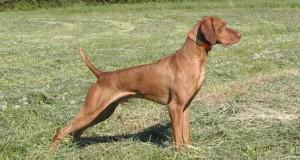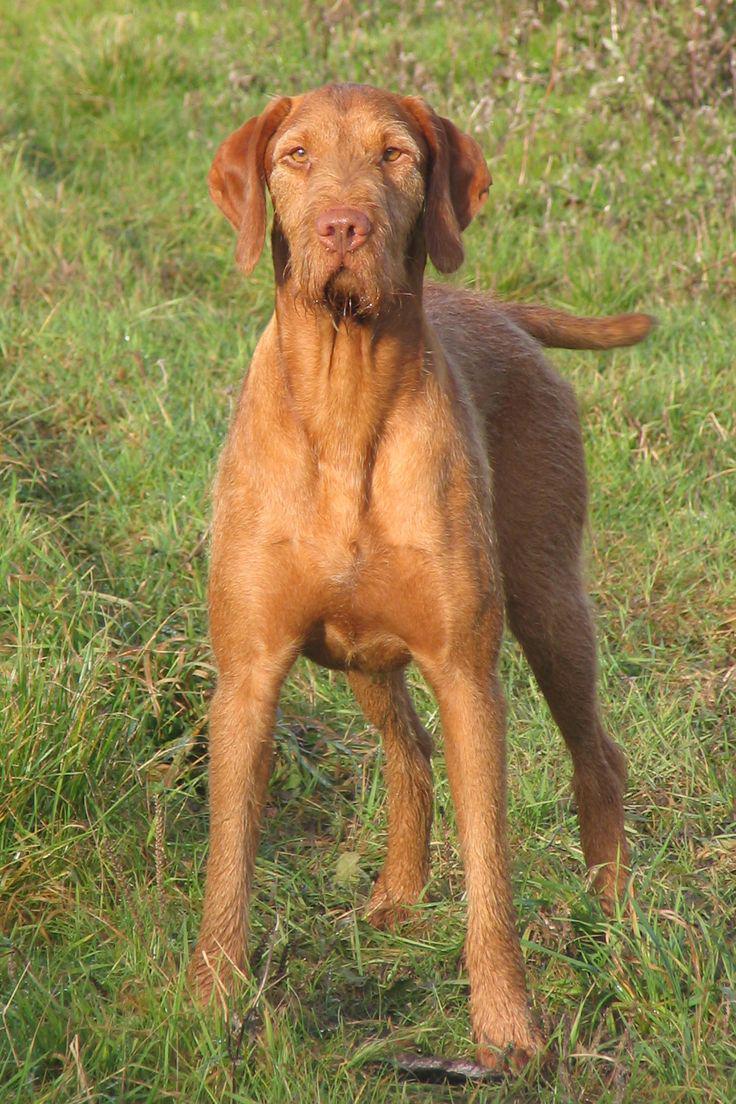The first image is the image on the left, the second image is the image on the right. For the images shown, is this caption "Both images contain a dog with their body facing toward the left." true? Answer yes or no. No. The first image is the image on the left, the second image is the image on the right. Examine the images to the left and right. Is the description "Both dogs are facing to the left of the images." accurate? Answer yes or no. No. 